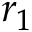<formula> <loc_0><loc_0><loc_500><loc_500>r _ { 1 }</formula> 